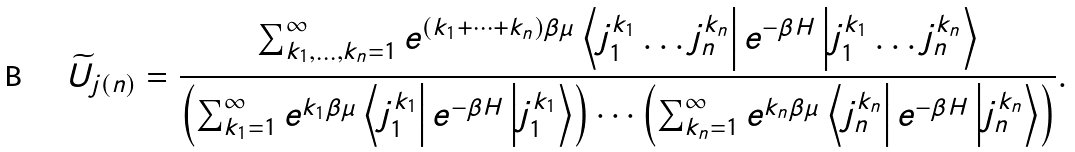<formula> <loc_0><loc_0><loc_500><loc_500>\widetilde { U } _ { j ( n ) } = \frac { \sum _ { k _ { 1 } , \dots , k _ { n } = 1 } ^ { \infty } e ^ { ( k _ { 1 } + \dots + k _ { n } ) \beta \mu } \left < j _ { 1 } ^ { k _ { 1 } } \dots j _ { n } ^ { k _ { n } } \right | e ^ { - \beta H } \left | j _ { 1 } ^ { k _ { 1 } } \dots j _ { n } ^ { k _ { n } } \right > } { \left ( \sum _ { k _ { 1 } = 1 } ^ { \infty } e ^ { k _ { 1 } \beta \mu } \left < j _ { 1 } ^ { k _ { 1 } } \right | e ^ { - \beta H } \left | j _ { 1 } ^ { k _ { 1 } } \right > \right ) \cdots \left ( \sum _ { k _ { n } = 1 } ^ { \infty } e ^ { k _ { n } \beta \mu } \left < j _ { n } ^ { k _ { n } } \right | e ^ { - \beta H } \left | j _ { n } ^ { k _ { n } } \right > \right ) } .</formula> 